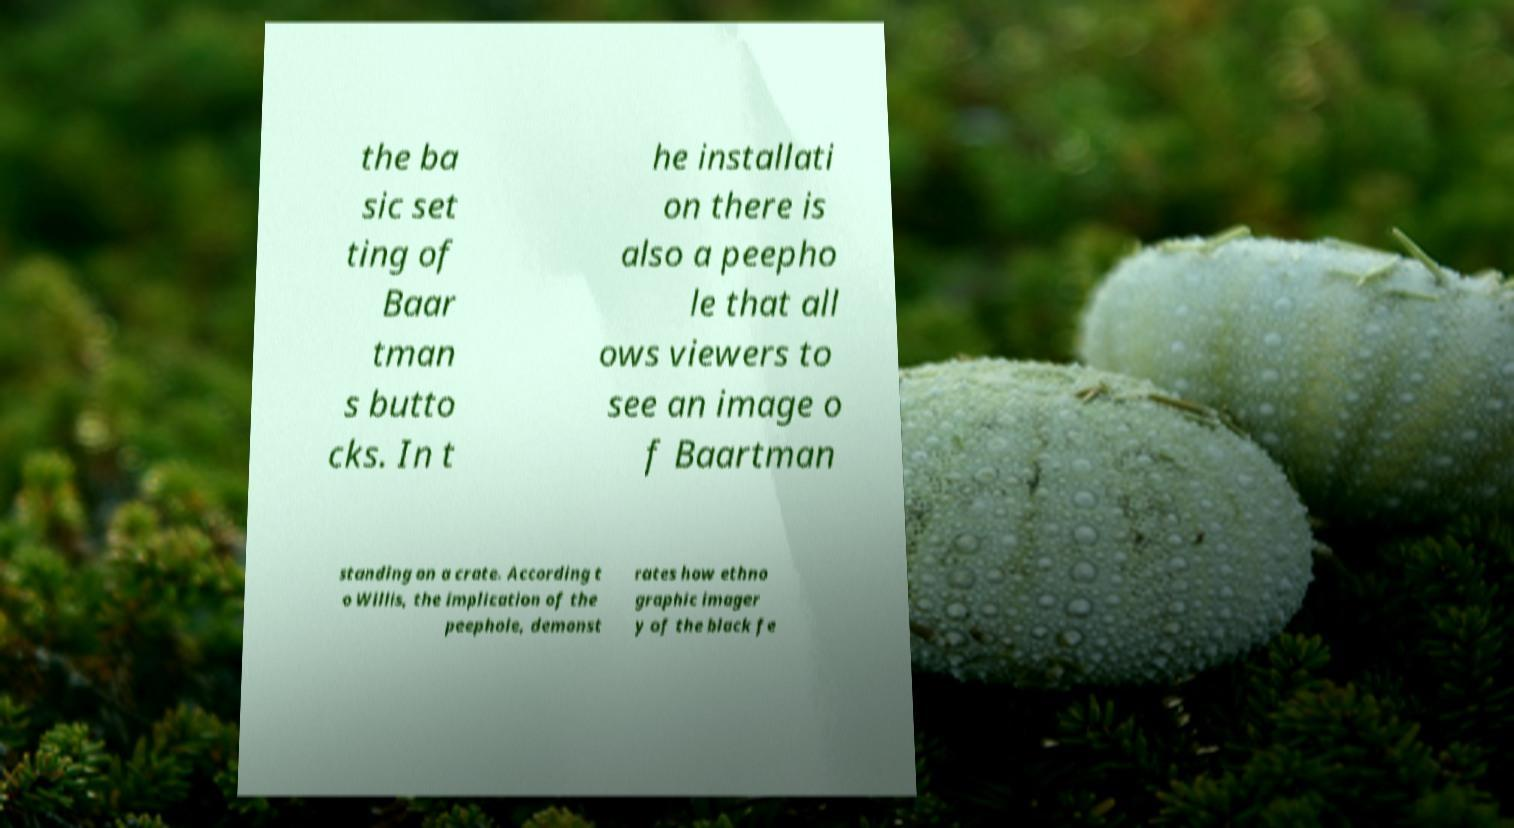Could you extract and type out the text from this image? the ba sic set ting of Baar tman s butto cks. In t he installati on there is also a peepho le that all ows viewers to see an image o f Baartman standing on a crate. According t o Willis, the implication of the peephole, demonst rates how ethno graphic imager y of the black fe 